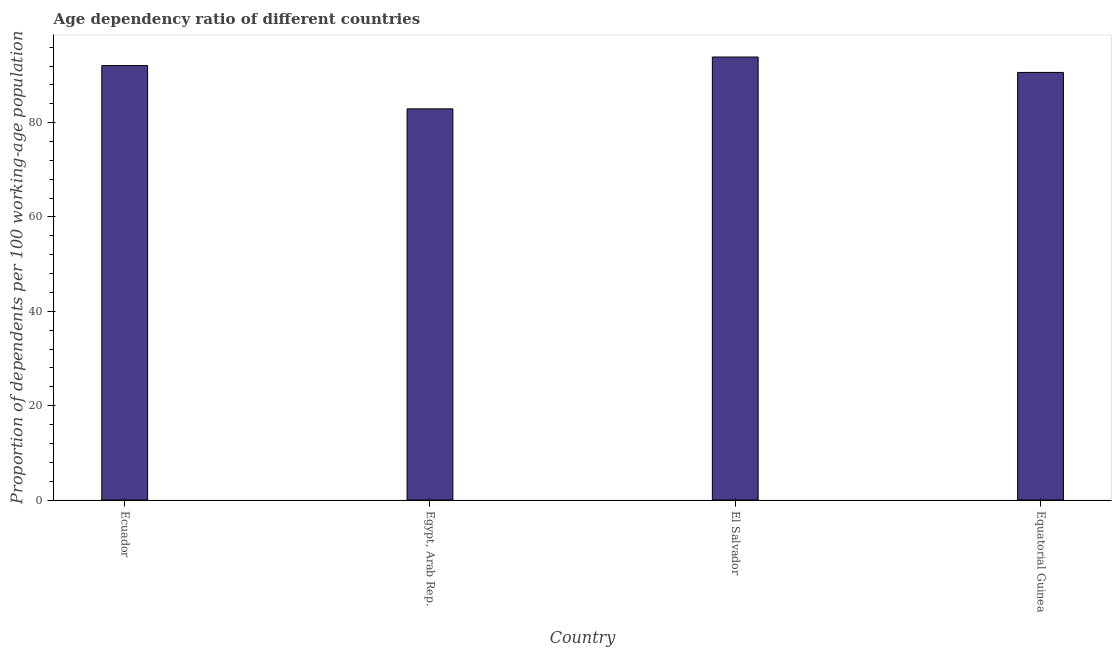Does the graph contain grids?
Keep it short and to the point. No. What is the title of the graph?
Make the answer very short. Age dependency ratio of different countries. What is the label or title of the Y-axis?
Your response must be concise. Proportion of dependents per 100 working-age population. What is the age dependency ratio in Equatorial Guinea?
Offer a very short reply. 90.65. Across all countries, what is the maximum age dependency ratio?
Ensure brevity in your answer.  93.92. Across all countries, what is the minimum age dependency ratio?
Offer a terse response. 82.93. In which country was the age dependency ratio maximum?
Ensure brevity in your answer.  El Salvador. In which country was the age dependency ratio minimum?
Make the answer very short. Egypt, Arab Rep. What is the sum of the age dependency ratio?
Offer a very short reply. 359.6. What is the difference between the age dependency ratio in Ecuador and El Salvador?
Provide a short and direct response. -1.81. What is the average age dependency ratio per country?
Keep it short and to the point. 89.9. What is the median age dependency ratio?
Your answer should be very brief. 91.38. Is the difference between the age dependency ratio in Ecuador and Egypt, Arab Rep. greater than the difference between any two countries?
Offer a very short reply. No. What is the difference between the highest and the second highest age dependency ratio?
Offer a very short reply. 1.81. Is the sum of the age dependency ratio in Egypt, Arab Rep. and Equatorial Guinea greater than the maximum age dependency ratio across all countries?
Your answer should be compact. Yes. What is the difference between the highest and the lowest age dependency ratio?
Offer a terse response. 10.99. How many countries are there in the graph?
Your answer should be very brief. 4. Are the values on the major ticks of Y-axis written in scientific E-notation?
Offer a terse response. No. What is the Proportion of dependents per 100 working-age population of Ecuador?
Provide a short and direct response. 92.11. What is the Proportion of dependents per 100 working-age population in Egypt, Arab Rep.?
Keep it short and to the point. 82.93. What is the Proportion of dependents per 100 working-age population of El Salvador?
Keep it short and to the point. 93.92. What is the Proportion of dependents per 100 working-age population in Equatorial Guinea?
Keep it short and to the point. 90.65. What is the difference between the Proportion of dependents per 100 working-age population in Ecuador and Egypt, Arab Rep.?
Ensure brevity in your answer.  9.18. What is the difference between the Proportion of dependents per 100 working-age population in Ecuador and El Salvador?
Make the answer very short. -1.81. What is the difference between the Proportion of dependents per 100 working-age population in Ecuador and Equatorial Guinea?
Keep it short and to the point. 1.45. What is the difference between the Proportion of dependents per 100 working-age population in Egypt, Arab Rep. and El Salvador?
Give a very brief answer. -10.99. What is the difference between the Proportion of dependents per 100 working-age population in Egypt, Arab Rep. and Equatorial Guinea?
Your answer should be very brief. -7.72. What is the difference between the Proportion of dependents per 100 working-age population in El Salvador and Equatorial Guinea?
Ensure brevity in your answer.  3.26. What is the ratio of the Proportion of dependents per 100 working-age population in Ecuador to that in Egypt, Arab Rep.?
Keep it short and to the point. 1.11. What is the ratio of the Proportion of dependents per 100 working-age population in Ecuador to that in El Salvador?
Offer a very short reply. 0.98. What is the ratio of the Proportion of dependents per 100 working-age population in Ecuador to that in Equatorial Guinea?
Provide a succinct answer. 1.02. What is the ratio of the Proportion of dependents per 100 working-age population in Egypt, Arab Rep. to that in El Salvador?
Offer a very short reply. 0.88. What is the ratio of the Proportion of dependents per 100 working-age population in Egypt, Arab Rep. to that in Equatorial Guinea?
Keep it short and to the point. 0.92. What is the ratio of the Proportion of dependents per 100 working-age population in El Salvador to that in Equatorial Guinea?
Your answer should be very brief. 1.04. 